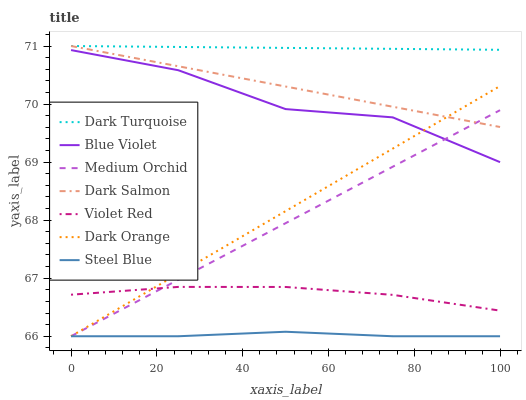Does Steel Blue have the minimum area under the curve?
Answer yes or no. Yes. Does Dark Turquoise have the maximum area under the curve?
Answer yes or no. Yes. Does Violet Red have the minimum area under the curve?
Answer yes or no. No. Does Violet Red have the maximum area under the curve?
Answer yes or no. No. Is Dark Orange the smoothest?
Answer yes or no. Yes. Is Blue Violet the roughest?
Answer yes or no. Yes. Is Violet Red the smoothest?
Answer yes or no. No. Is Violet Red the roughest?
Answer yes or no. No. Does Dark Orange have the lowest value?
Answer yes or no. Yes. Does Violet Red have the lowest value?
Answer yes or no. No. Does Dark Salmon have the highest value?
Answer yes or no. Yes. Does Violet Red have the highest value?
Answer yes or no. No. Is Violet Red less than Dark Turquoise?
Answer yes or no. Yes. Is Dark Turquoise greater than Dark Orange?
Answer yes or no. Yes. Does Violet Red intersect Medium Orchid?
Answer yes or no. Yes. Is Violet Red less than Medium Orchid?
Answer yes or no. No. Is Violet Red greater than Medium Orchid?
Answer yes or no. No. Does Violet Red intersect Dark Turquoise?
Answer yes or no. No. 